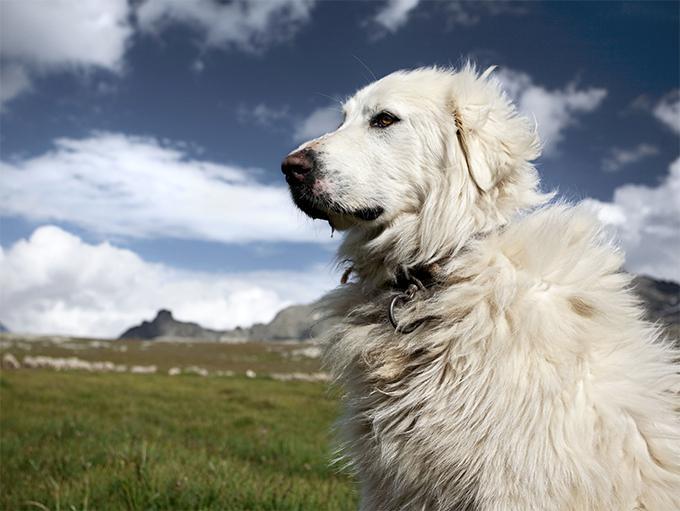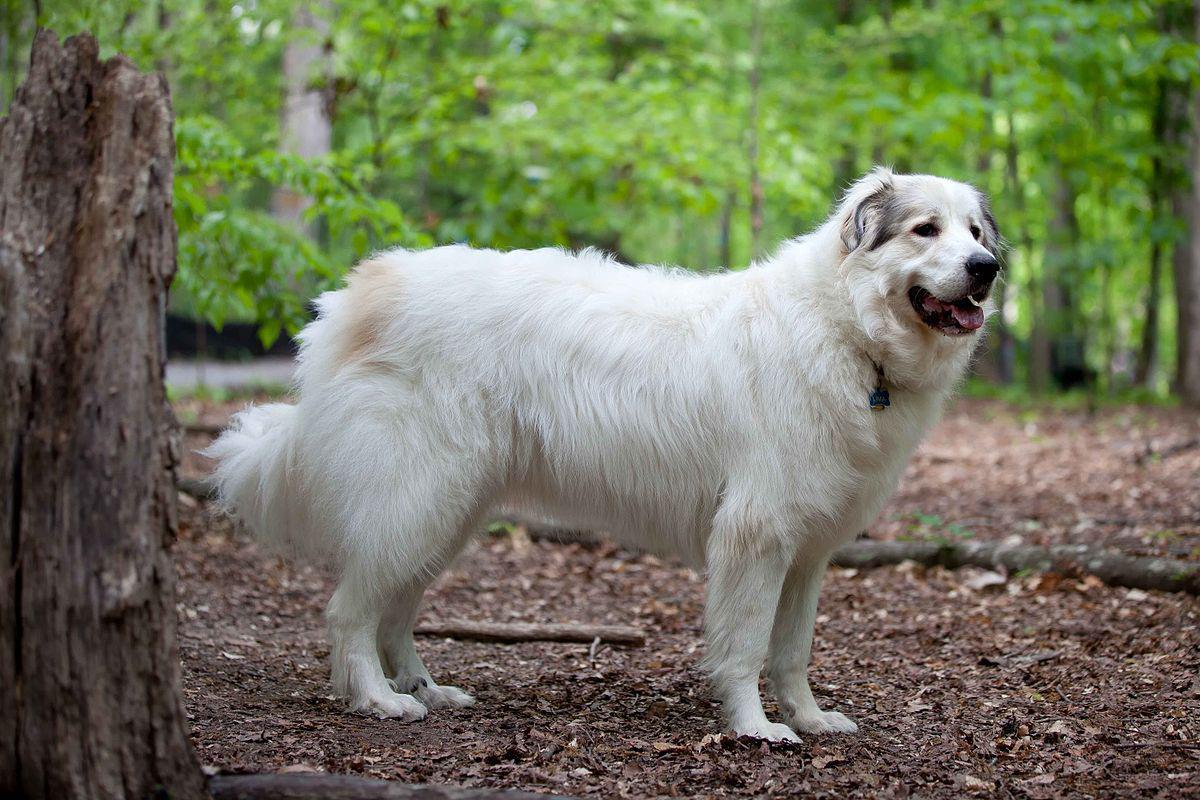The first image is the image on the left, the second image is the image on the right. Analyze the images presented: Is the assertion "One image contains more than one dog." valid? Answer yes or no. No. The first image is the image on the left, the second image is the image on the right. Examine the images to the left and right. Is the description "There are no more than two dogs." accurate? Answer yes or no. Yes. 